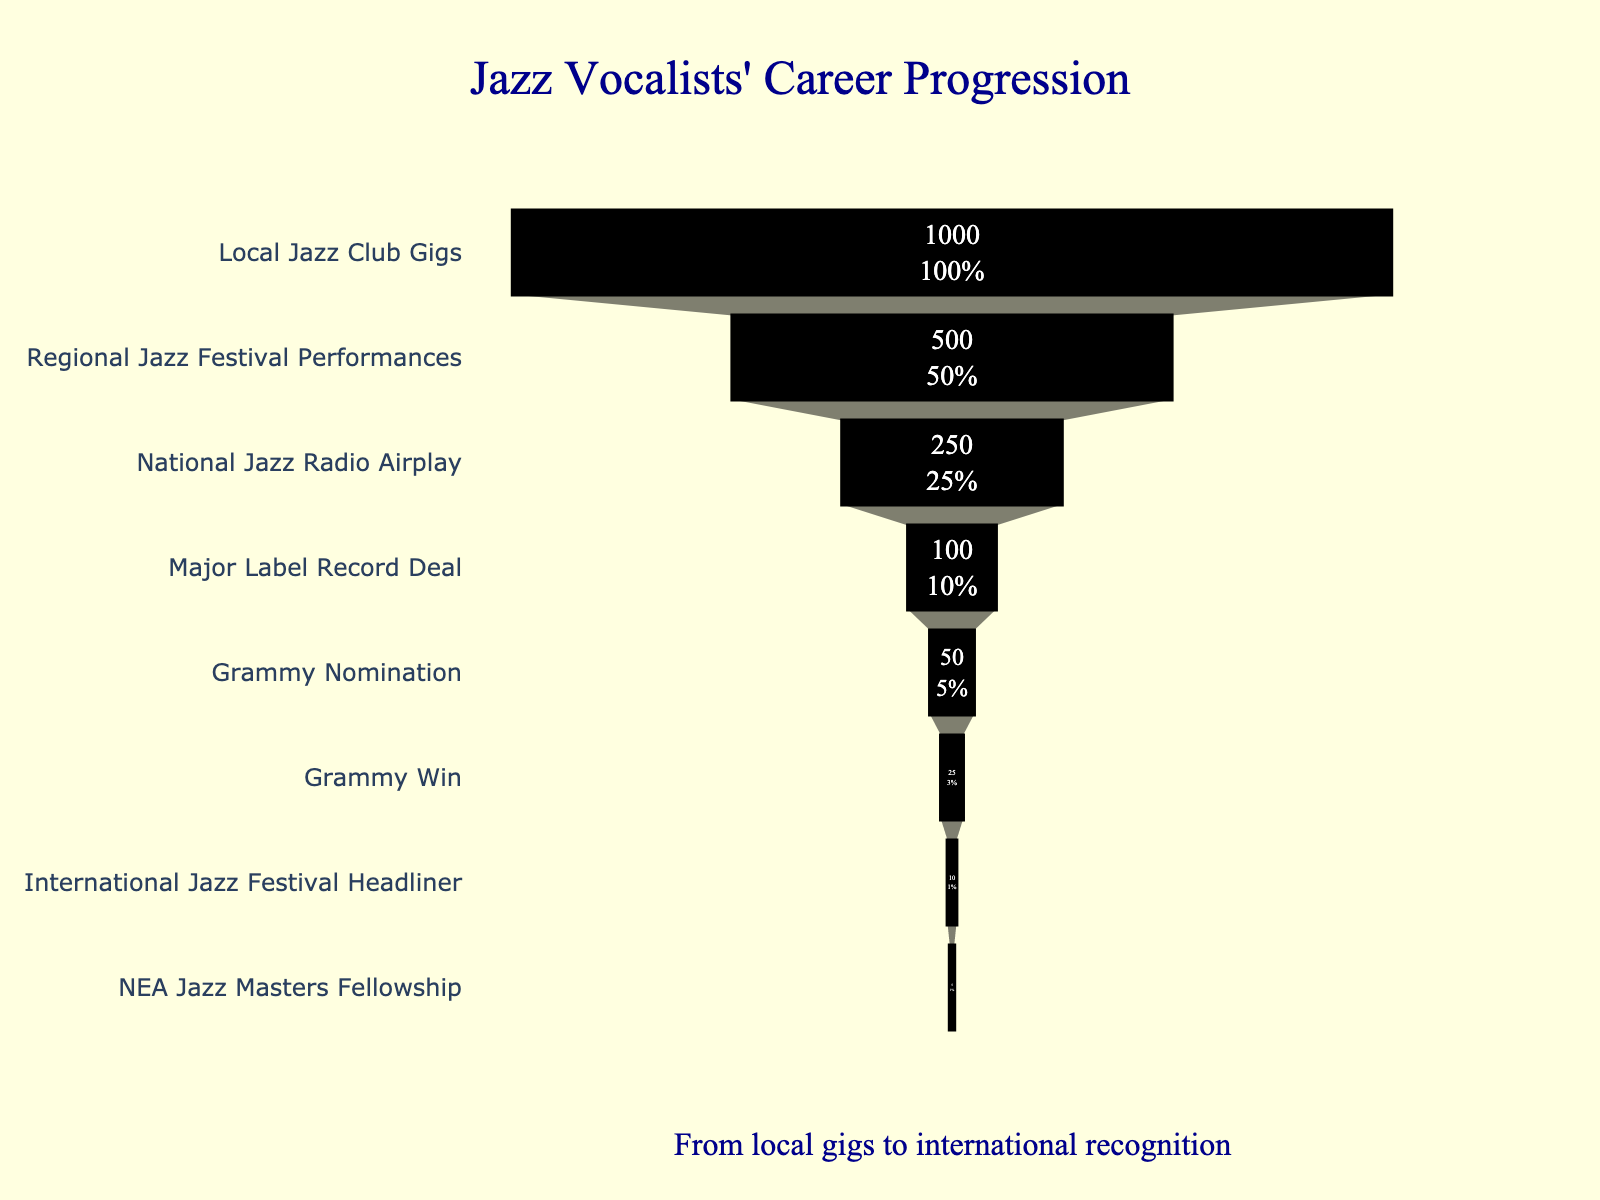What's the title of the funnel chart? The title is shown prominently at the top of the chart, usually in a larger and bold font to grab attention.
Answer: Jazz Vocalists' Career Progression How many stages are shown in the funnel chart? By counting the different categories listed from top to bottom, you can determine the number of stages.
Answer: 8 Which stage has the largest number of vocalists? Look at the top part of the funnel where the width is the widest, indicating the highest value.
Answer: Local Jazz Club Gigs How many vocalists make it to the Grammy nomination stage? Identify the stage labeled 'Grammy Nomination' and look at the number of vocalists indicated next to it.
Answer: 50 What is the percentage of vocalists from the regional jazz festival who reach the national jazz radio airplay stage? Divide the number of vocalists in the national jazz radio airplay stage by those in the regional jazz festival stage and multiply by 100. (250/500)*100
Answer: 50% How many fewer vocalists receive a Grammy win compared to those who get a major label record deal? Subtract the number of Grammy-winning vocalists from those who have a major label record deal. 100 - 25 = 75
Answer: 75 What's the total number of vocalists from the beginning to the end of the funnel? Sum the numbers of vocalists at each stage from top to bottom. 1000 + 500 + 250 + 100 + 50 + 25 + 10 + 5 = 1940
Answer: 1940 Which stage has the smallest number of vocalists? Look at the bottom part of the funnel where the width is the narrowest, indicating the smallest value.
Answer: NEA Jazz Masters Fellowship How does the number of vocalists who headline international jazz festivals compare to those who win a Grammy? Compare the numerical values for 'International Jazz Festival Headliner' and 'Grammy Win' stages. 10 < 25
Answer: Grammy Win > International Jazz Festival Headliner What percentage of vocalists who get a Grammy nomination actually win the Grammy? Divide the number of Grammy-winning vocalists by the number of Grammy-nominated vocalists and multiply by 100. (25/50)*100
Answer: 50% 